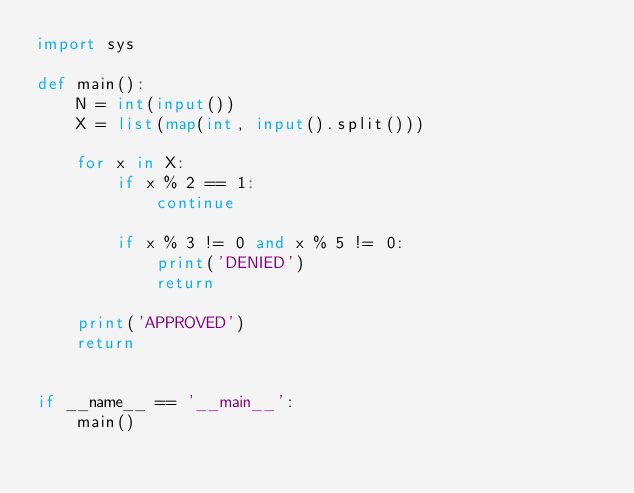Convert code to text. <code><loc_0><loc_0><loc_500><loc_500><_Python_>import sys

def main():
    N = int(input())
    X = list(map(int, input().split()))

    for x in X:
        if x % 2 == 1:
            continue

        if x % 3 != 0 and x % 5 != 0:
            print('DENIED')
            return

    print('APPROVED')
    return


if __name__ == '__main__':
    main()</code> 